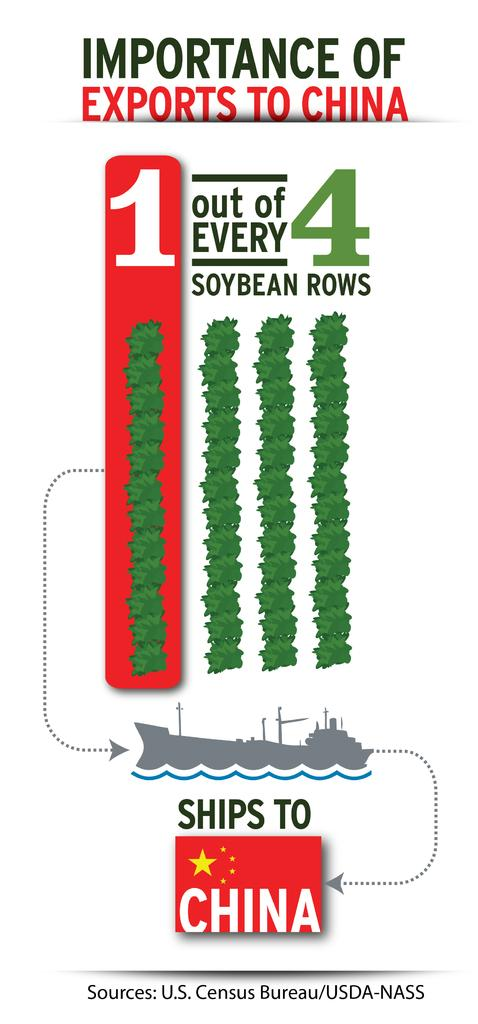<image>
Share a concise interpretation of the image provided. The importance of exports to China is that 1 out of every 4 rows of soybean rows is shipped to China. 